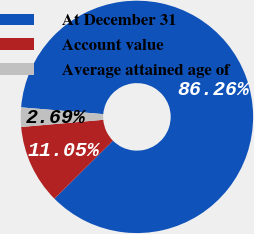Convert chart. <chart><loc_0><loc_0><loc_500><loc_500><pie_chart><fcel>At December 31<fcel>Account value<fcel>Average attained age of<nl><fcel>86.26%<fcel>11.05%<fcel>2.69%<nl></chart> 